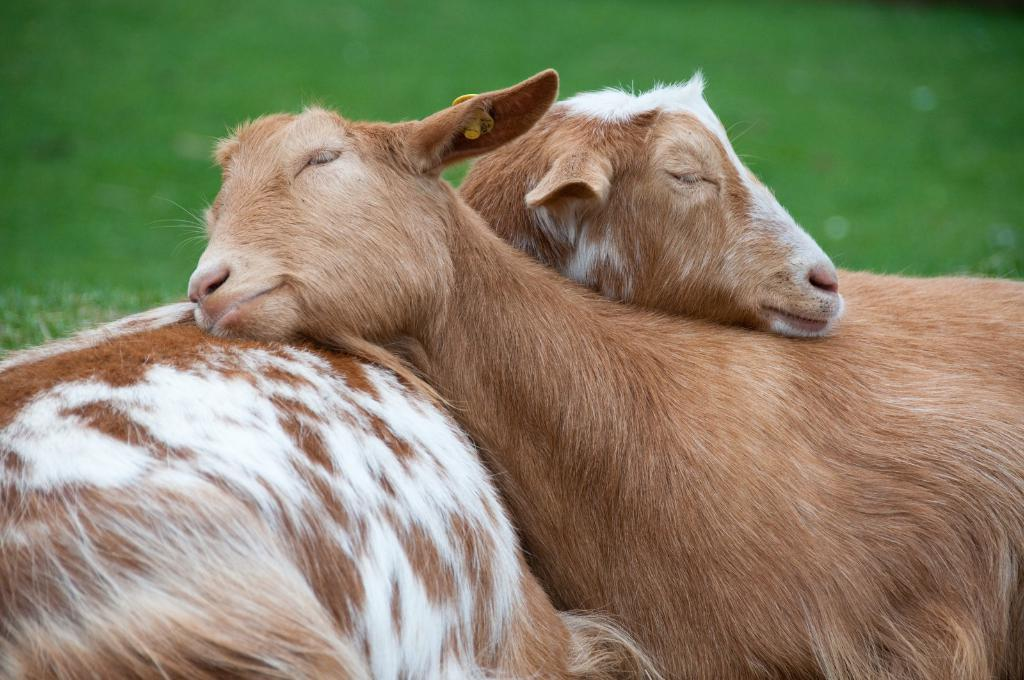What type of animals are present in the image? There are sheep in the image. What can be seen in the background of the image? There is grass in the background of the image. What scientific discovery is being made by the sheep in the image? There is no scientific discovery being made by the sheep in the image; they are simply grazing in a grassy area. Can you see the thumb of any sheep in the image? Sheep do not have thumbs, so it is not possible to see a thumb in the image. 